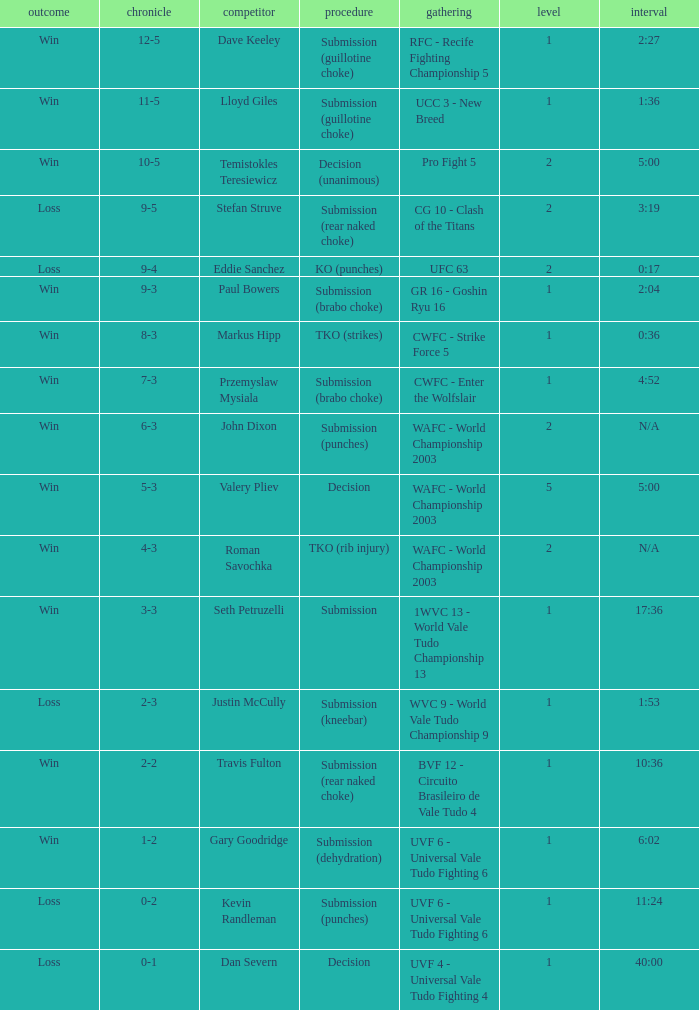What opponent uses the method of decision and a 5-3 record? Valery Pliev. 